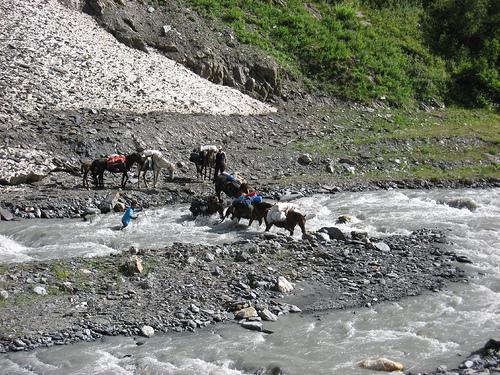What color is the first horse?
Quick response, please. Brown. How many people are shown?
Concise answer only. 2. Is the water calm or rough?
Concise answer only. Rough. Is there a lot of snow on the ground?
Quick response, please. No. Can the horses cross the water?
Keep it brief. Yes. 